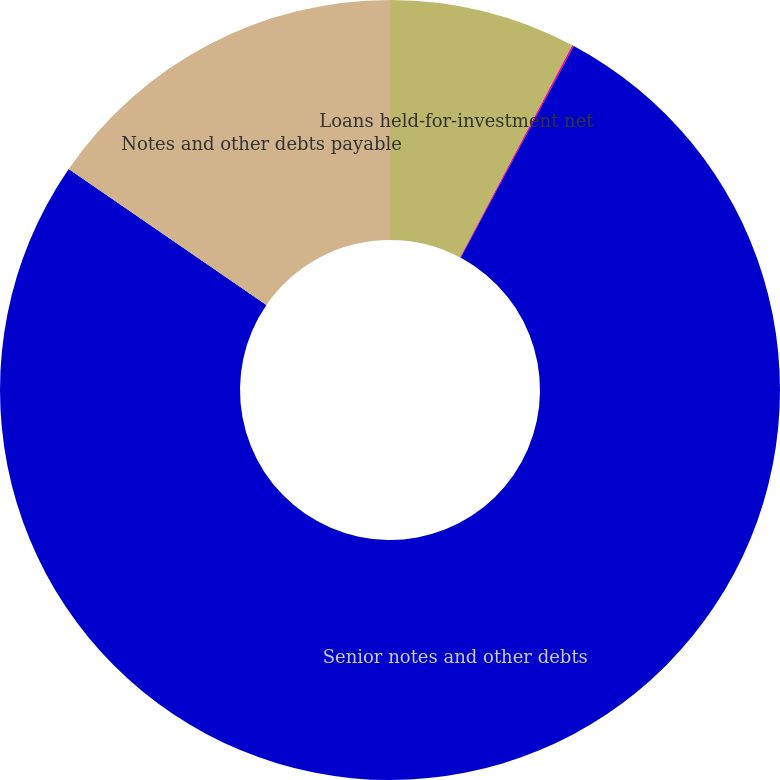<chart> <loc_0><loc_0><loc_500><loc_500><pie_chart><fcel>Loans held-for-investment net<fcel>Investments-held-to-maturity<fcel>Senior notes and other debts<fcel>Notes and other debts payable<nl><fcel>7.74%<fcel>0.07%<fcel>76.78%<fcel>15.41%<nl></chart> 